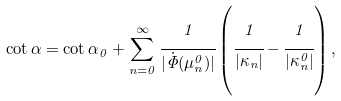Convert formula to latex. <formula><loc_0><loc_0><loc_500><loc_500>\cot \alpha = \cot \alpha _ { 0 } + \sum _ { n = 0 } ^ { \infty } \cfrac { 1 } { | \dot { \Phi } ( \mu _ { n } ^ { 0 } ) | } \left ( \cfrac { 1 } { | \kappa _ { n } | } - \cfrac { 1 } { | \kappa _ { n } ^ { 0 } | } \right ) ,</formula> 